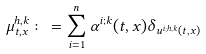<formula> <loc_0><loc_0><loc_500><loc_500>\mu ^ { h , k } _ { t , x } \colon = \sum _ { i = 1 } ^ { n } \alpha ^ { i ; k } ( t , x ) \delta _ { u ^ { i ; h , k } ( t , x ) }</formula> 